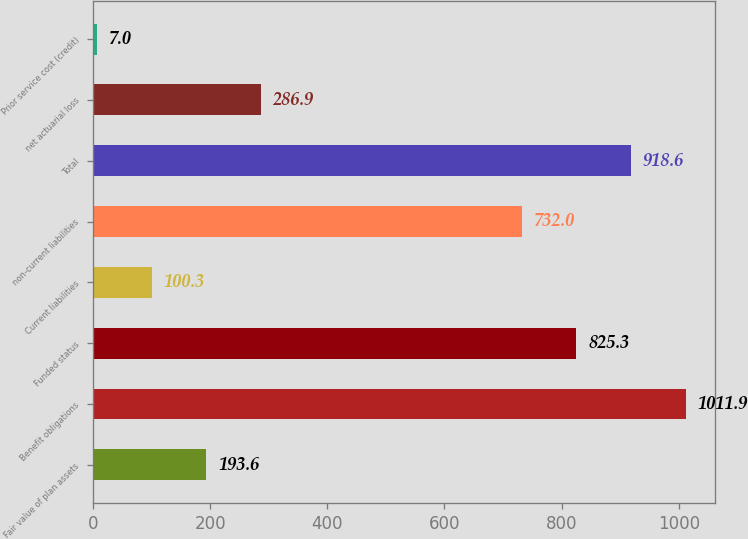<chart> <loc_0><loc_0><loc_500><loc_500><bar_chart><fcel>Fair value of plan assets<fcel>Benefit obligations<fcel>Funded status<fcel>Current liabilities<fcel>non-current liabilities<fcel>Total<fcel>net actuarial loss<fcel>Prior service cost (credit)<nl><fcel>193.6<fcel>1011.9<fcel>825.3<fcel>100.3<fcel>732<fcel>918.6<fcel>286.9<fcel>7<nl></chart> 